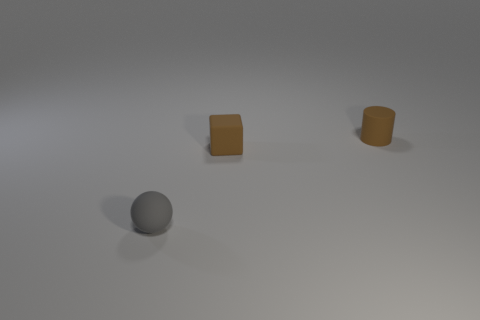Add 1 rubber blocks. How many objects exist? 4 Subtract all cylinders. How many objects are left? 2 Add 1 tiny matte objects. How many tiny matte objects are left? 4 Add 2 tiny brown matte cylinders. How many tiny brown matte cylinders exist? 3 Subtract 0 red blocks. How many objects are left? 3 Subtract all big cyan things. Subtract all brown matte things. How many objects are left? 1 